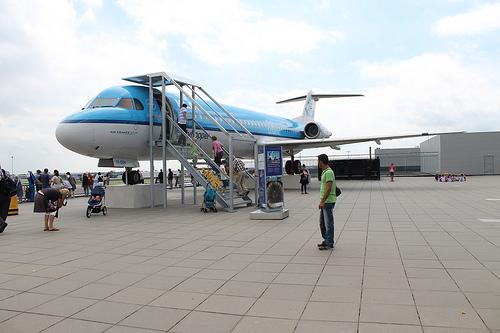What are some additional details about the baby stroller and its surroundings? The baby stroller has three wheels and is located near a lady holding a child, a woman in a purple shirt boarding the plane, and a blue baby stroller. Can you describe a small portion of the scene not directly related to the airplane? Several people are looking behind a fence, possibly observing the airplane or waiting for someone. Mention one activity that a group of people is doing in the image. A group of people is sitting on the ground, possibly in a circle. Identify the primary object in the image, along with any notable colors and additional details. The main object is a blue and white airplane, parked with its ramp open and people boarding. Choose a person wearing a specific color shirt and describe them. A woman in a purple shirt with short hair is boarding the airplane. What is happening with the baby in the image? A baby is inside a three-wheeled baby stroller, possibly being looked after by a lady holding a child nearby. Provide a detail about a woman who is capturing a moment in the image. A blonde woman is bent over in a skirt, taking a picture. What is a man in a green shirt and blue jeans doing in the image? The man in a green shirt and blue jeans is standing and looking away from the main scene. Please name two notable features or objects related to the airplane. The airplane has its four front windows visible and a metal staircase going to its entrance. Please describe the setting of the image and any noticeable weather conditions. The setting is an open area with an airplane parked and people nearby. The sky is blue with white clouds scattered throughout. 